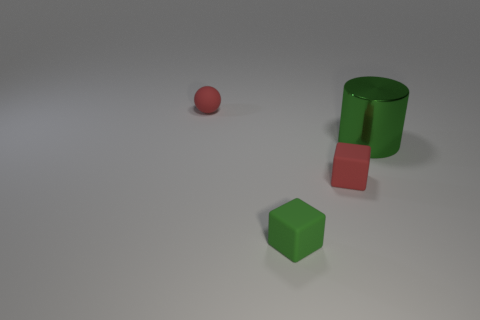Can you describe the objects in this image in terms of their shapes and colors? Certainly! There are three objects: a green cylinder, a red sphere, and a green cube. The green cylinder and cube share the same shade, while the sphere is a distinct reddish-pink color. 